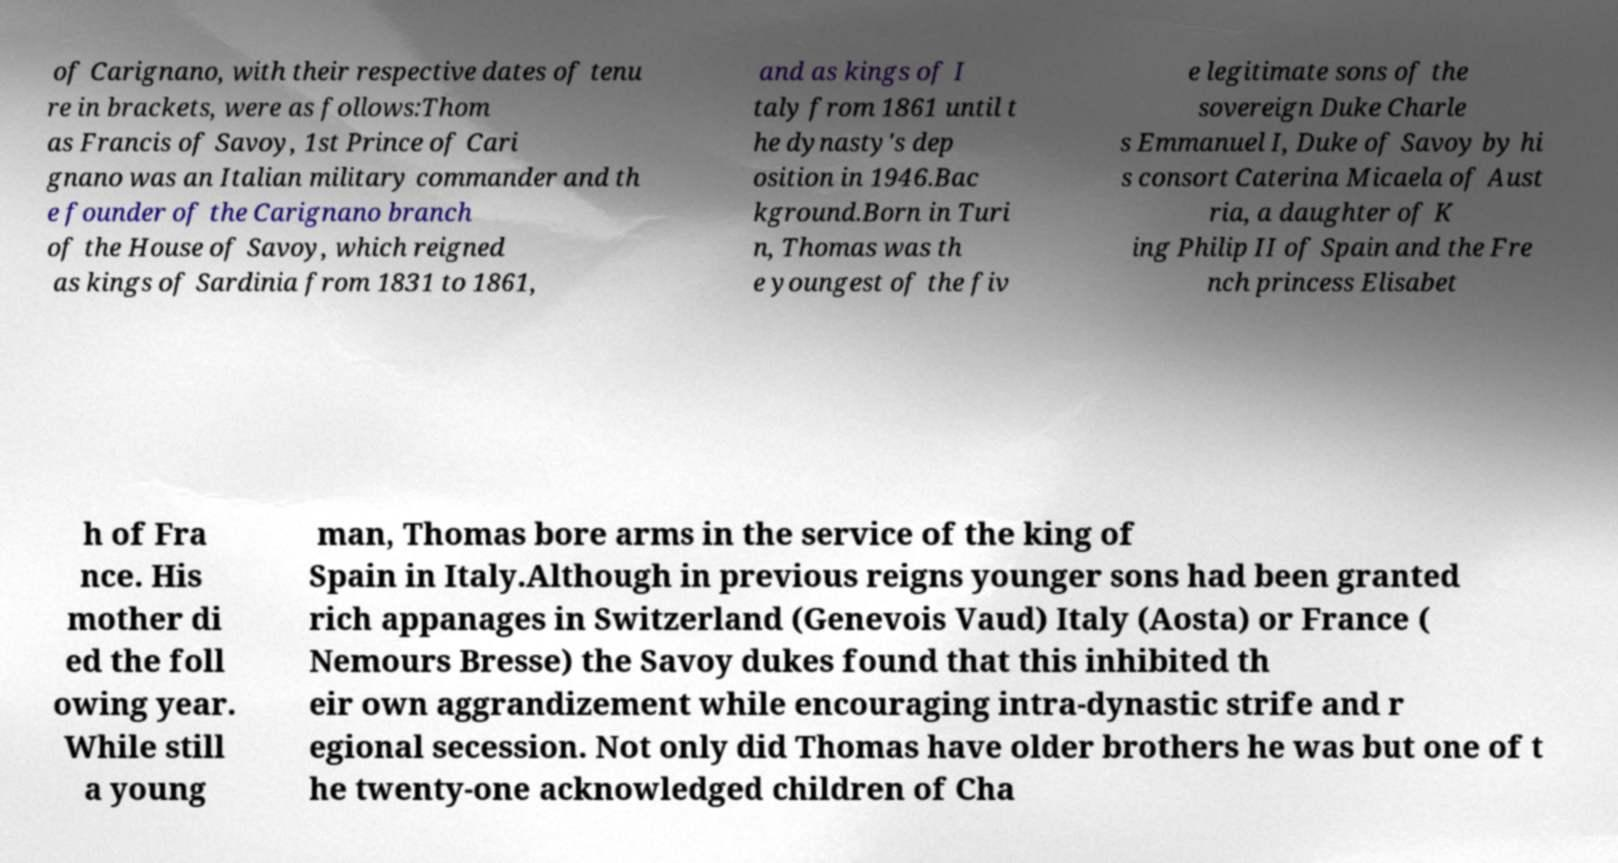I need the written content from this picture converted into text. Can you do that? of Carignano, with their respective dates of tenu re in brackets, were as follows:Thom as Francis of Savoy, 1st Prince of Cari gnano was an Italian military commander and th e founder of the Carignano branch of the House of Savoy, which reigned as kings of Sardinia from 1831 to 1861, and as kings of I taly from 1861 until t he dynasty's dep osition in 1946.Bac kground.Born in Turi n, Thomas was th e youngest of the fiv e legitimate sons of the sovereign Duke Charle s Emmanuel I, Duke of Savoy by hi s consort Caterina Micaela of Aust ria, a daughter of K ing Philip II of Spain and the Fre nch princess Elisabet h of Fra nce. His mother di ed the foll owing year. While still a young man, Thomas bore arms in the service of the king of Spain in Italy.Although in previous reigns younger sons had been granted rich appanages in Switzerland (Genevois Vaud) Italy (Aosta) or France ( Nemours Bresse) the Savoy dukes found that this inhibited th eir own aggrandizement while encouraging intra-dynastic strife and r egional secession. Not only did Thomas have older brothers he was but one of t he twenty-one acknowledged children of Cha 